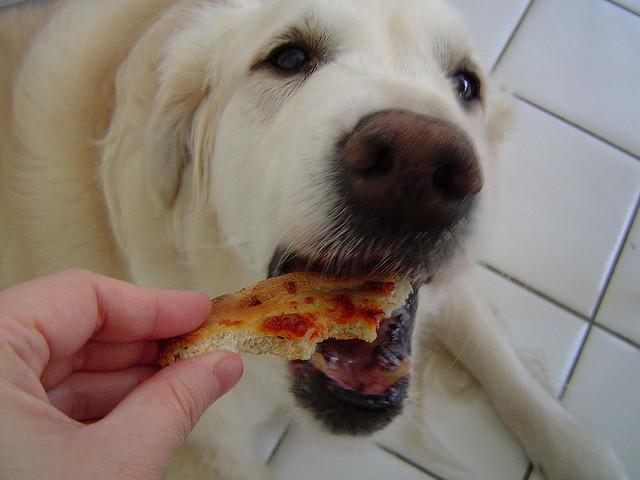What is the dog chowing down on?
Indicate the correct response and explain using: 'Answer: answer
Rationale: rationale.'
Options: Pizza, egg, baseball glove, shoes. Answer: pizza.
Rationale: The food is a crust bread with red sauce. 